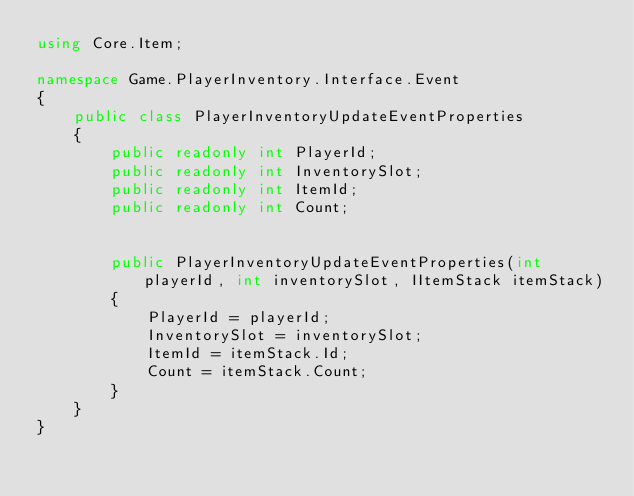Convert code to text. <code><loc_0><loc_0><loc_500><loc_500><_C#_>using Core.Item;

namespace Game.PlayerInventory.Interface.Event
{
    public class PlayerInventoryUpdateEventProperties
    {
        public readonly int PlayerId;
        public readonly int InventorySlot;
        public readonly int ItemId;
        public readonly int Count;


        public PlayerInventoryUpdateEventProperties(int playerId, int inventorySlot, IItemStack itemStack)
        {
            PlayerId = playerId;
            InventorySlot = inventorySlot;
            ItemId = itemStack.Id;
            Count = itemStack.Count;
        }
    }
}</code> 